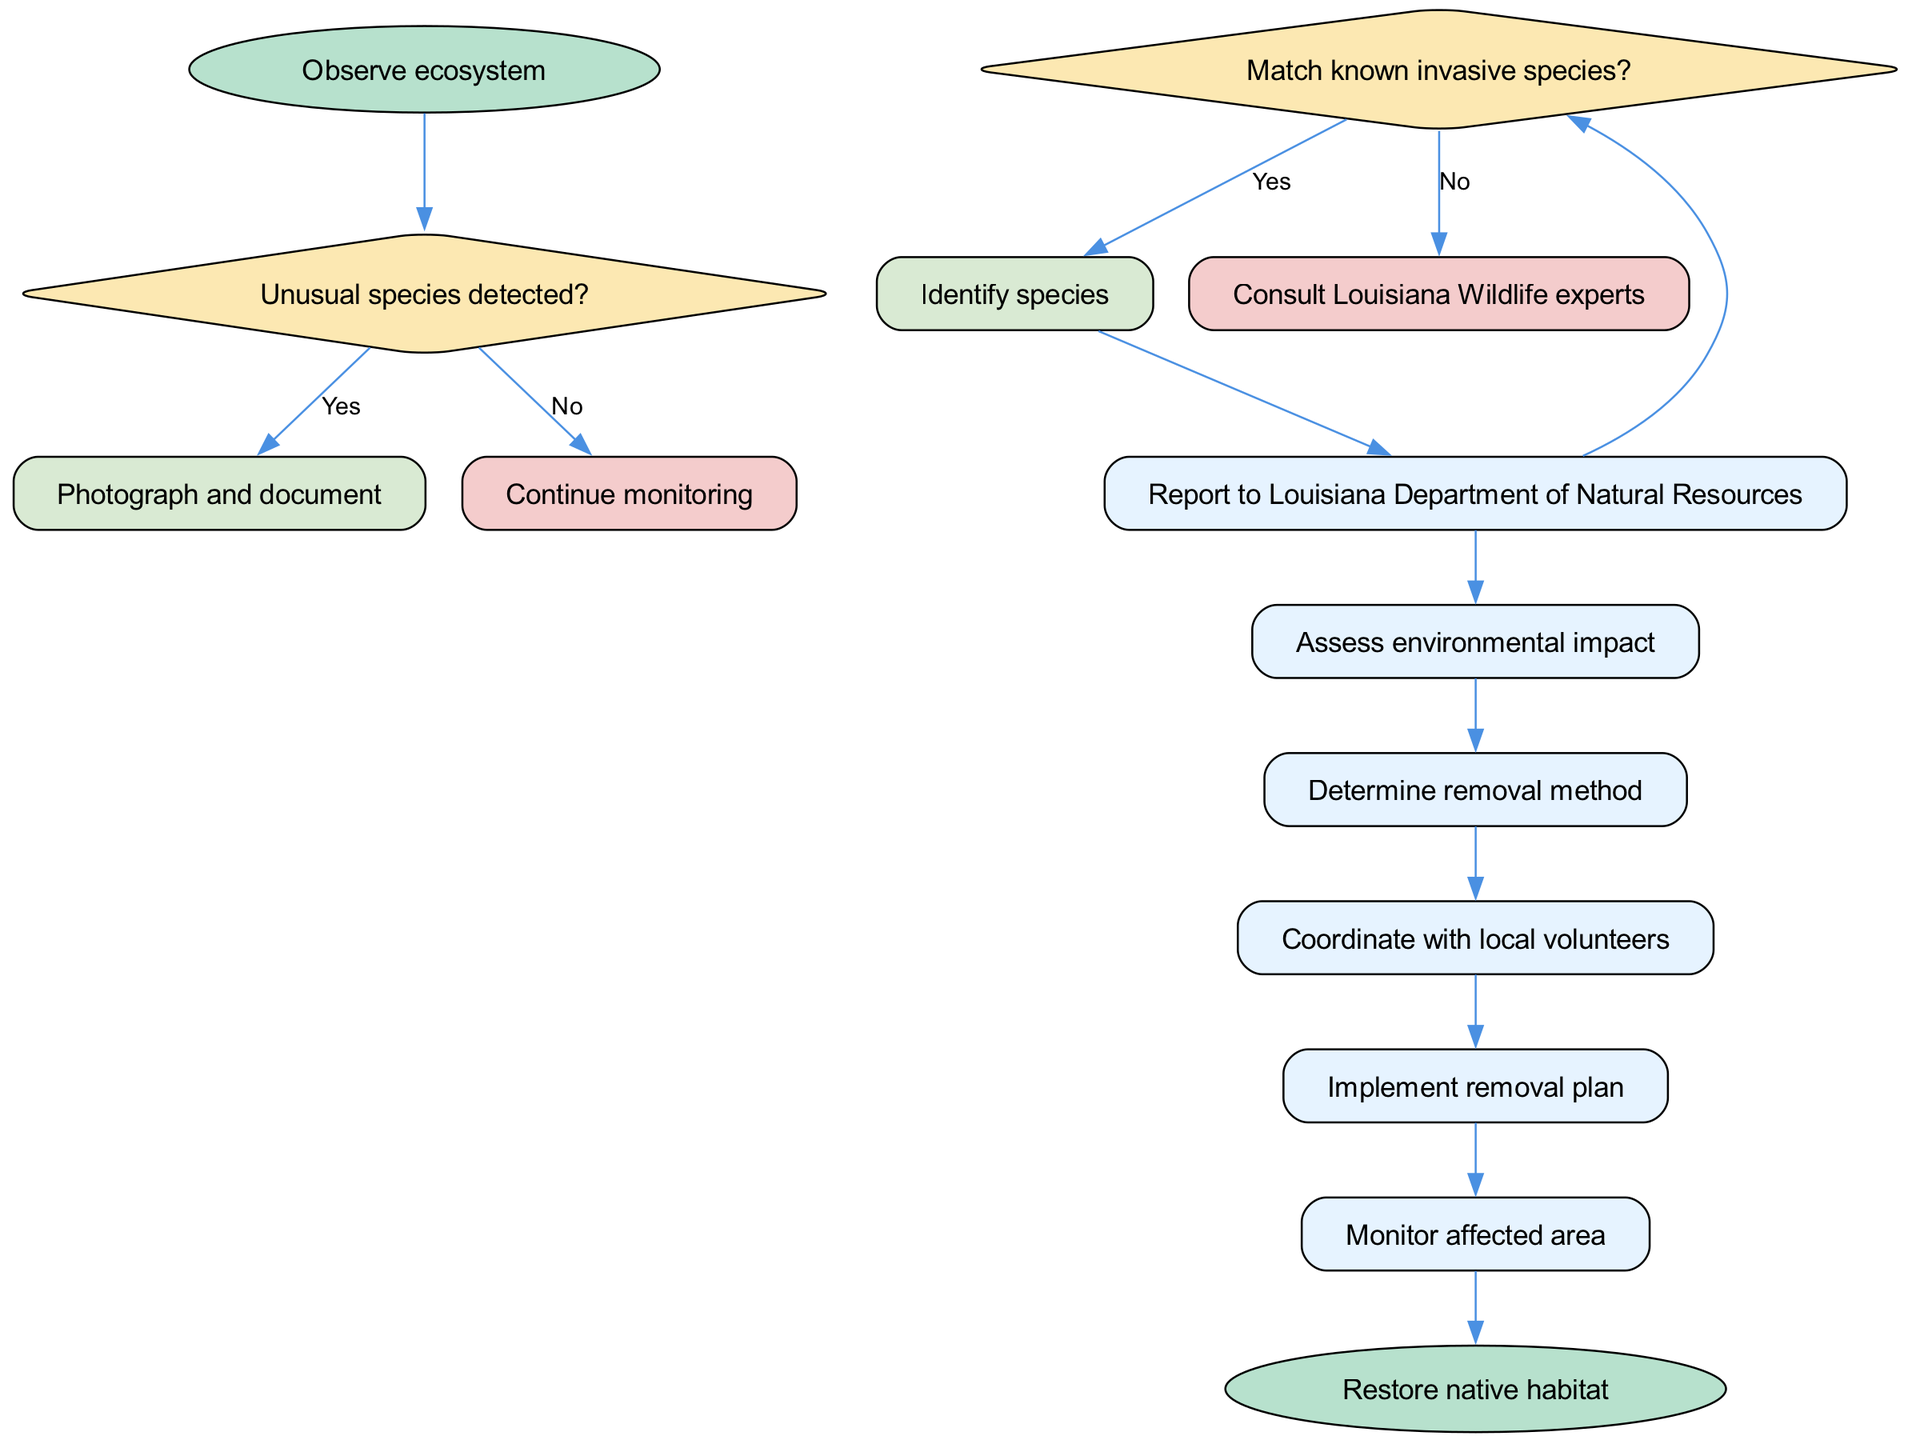What is the starting node in the diagram? The starting node is labeled "Observe ecosystem." It is the first point of action in the flowchart before any decisions are made.
Answer: Observe ecosystem How many decision nodes are present in the diagram? There are two decision nodes: one for detecting unusual species and the other for matching known invasive species. Therefore, the total count of decision nodes is two.
Answer: 2 What action follows after identifying an unusual species? Once an unusual species is identified (the "yes" branch of the first decision node), the next action is to "Photograph and document" the species.
Answer: Photograph and document What happens if no unusual species are detected? If no unusual species are detected (the "no" branch of the first decision node), the protocol advises to "Continue monitoring," which means the observation continues without further action.
Answer: Continue monitoring What is the final step in the process? The final step, as indicated by the end node, is to "Restore native habitat," which concludes the removal protocol and marks the restoration of the ecosystem.
Answer: Restore native habitat What is the action taken after consulting the Louisiana Wildlife experts? After consulting the experts, the next step is to "Report to Louisiana Department of Natural Resources," which initiates the official reporting process for invasive species.
Answer: Report to Louisiana Department of Natural Resources Which process is directly after assessing environmental impact? Following the "Assess environmental impact" process, the next action specified in the flowchart is to "Determine removal method," outlining the subsequent steps for addressing the invasive species.
Answer: Determine removal method Which decision flows into the process of coordinating with local volunteers? The decision that leads into coordinating with local volunteers is the affirmative identification of the invasive species (from the "yes" branch of the second decision node, "Match known invasive species?"). After confirming this, the protocol moves to mobilizing local support.
Answer: Identify species 